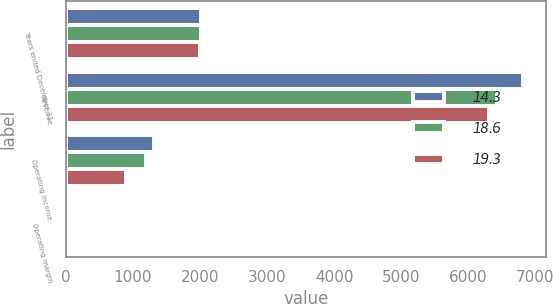Convert chart to OTSL. <chart><loc_0><loc_0><loc_500><loc_500><stacked_bar_chart><ecel><fcel>Years ended December 31<fcel>Revenue<fcel>Operating income<fcel>Operating margin<nl><fcel>14.3<fcel>2011<fcel>6817<fcel>1314<fcel>19.3<nl><fcel>18.6<fcel>2010<fcel>6423<fcel>1194<fcel>18.6<nl><fcel>19.3<fcel>2009<fcel>6305<fcel>900<fcel>14.3<nl></chart> 